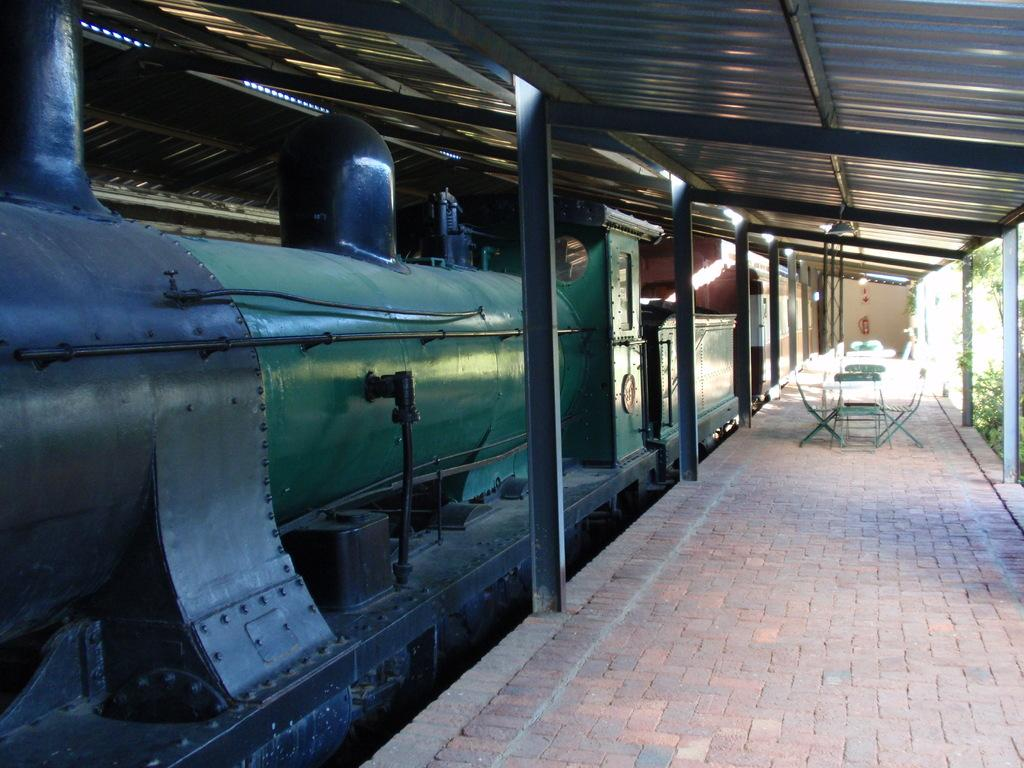What is the main subject of the image? The main subject of the image is a train engine. What else can be seen in the image besides the train engine? There is a platform, chairs, iron pillars, a shed, and plants on the right side of the image. What type of crack can be seen on the train engine in the image? There is no crack visible on the train engine in the image. Is there a bell present on the train engine in the image? There is no bell present on the train engine in the image. 